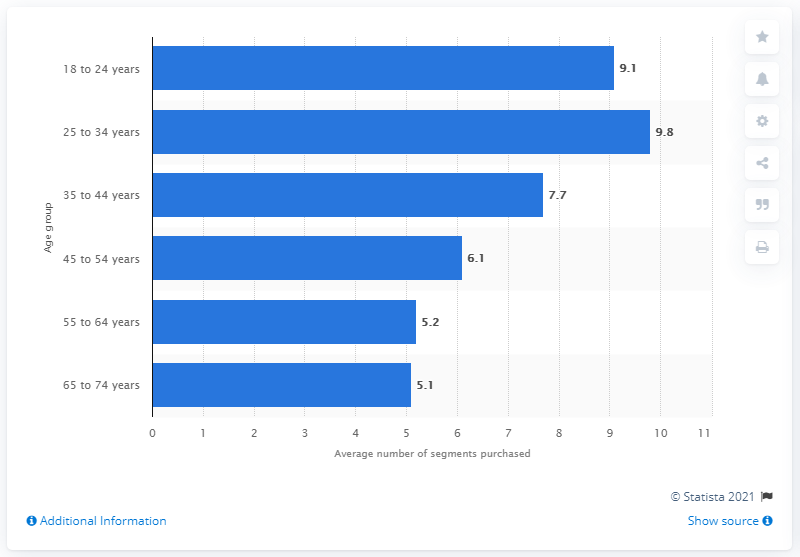Specify some key components in this picture. According to the data, women between the ages of 25 and 34 purchase an average of 9.8 beauty segments per year. 